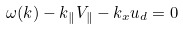Convert formula to latex. <formula><loc_0><loc_0><loc_500><loc_500>\omega ( { k } ) - k _ { \| } V _ { \| } - k _ { x } u _ { d } = 0</formula> 